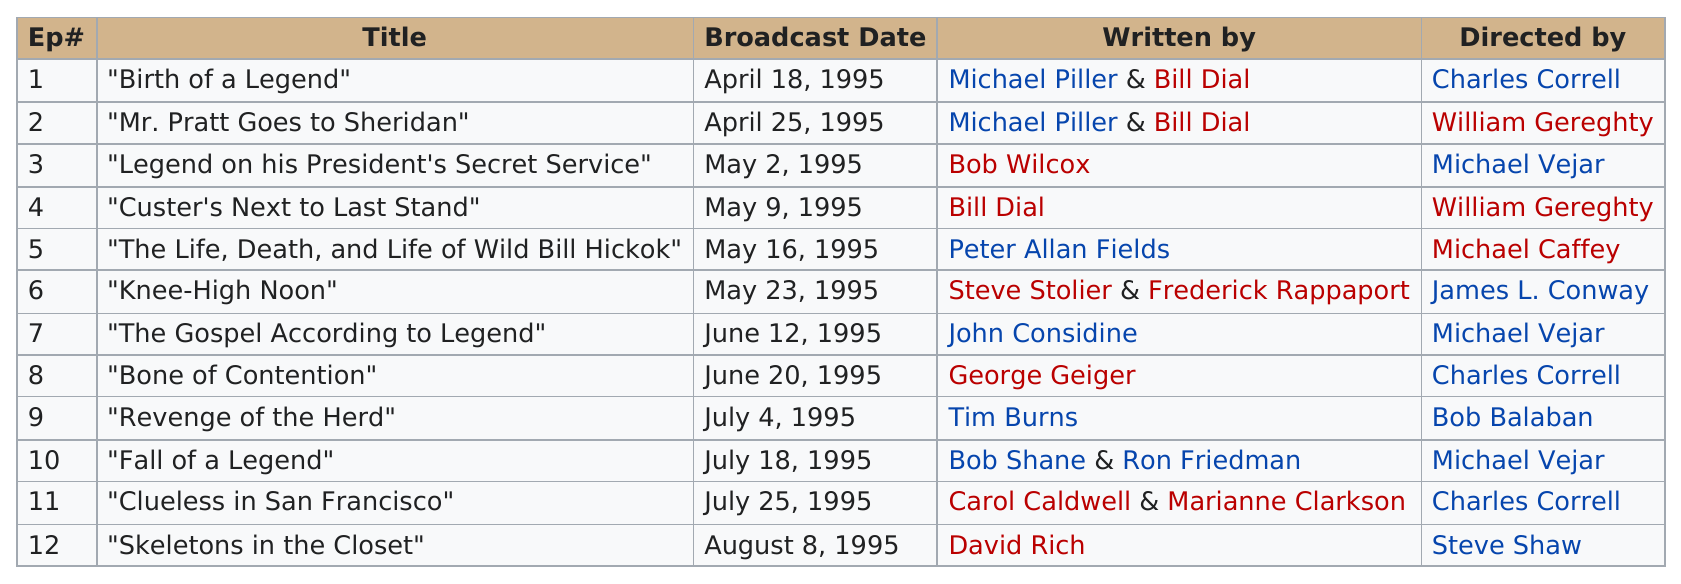Specify some key components in this picture. The title of the episode that preceded the one directed by Bob Balaban is "Bone of Contention. The only episode that aired in August 1995 is 'Skeletons in the Closet.' Thirty-one of the episodes were broadcast in July. Bill Dial has written or co-written a total of three episodes. The episode titled 'Birth of a Legend' aired first, before 'Skeletons in the Closet.' 